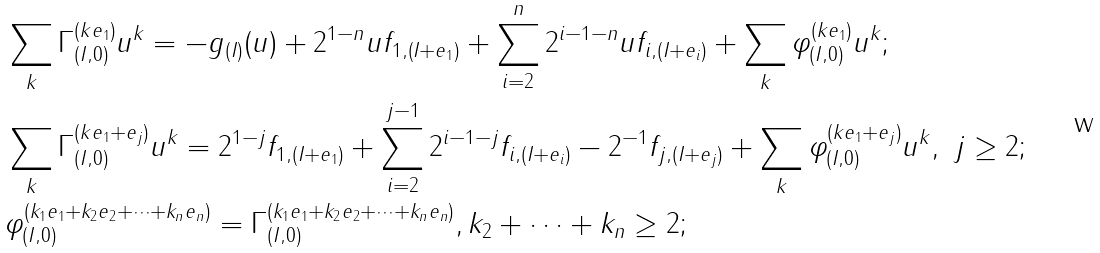<formula> <loc_0><loc_0><loc_500><loc_500>& \sum _ { k } \Gamma _ { ( I , 0 ) } ^ { ( k e _ { 1 } ) } u ^ { k } = - g _ { ( I ) } ( u ) + 2 ^ { 1 - n } u f _ { 1 , ( I + e _ { 1 } ) } + \sum _ { i = 2 } ^ { n } 2 ^ { i - 1 - n } u f _ { i , ( I + e _ { i } ) } + \sum _ { k } \varphi _ { ( I , 0 ) } ^ { ( k e _ { 1 } ) } u ^ { k } ; \\ & \sum _ { k } \Gamma _ { ( I , 0 ) } ^ { ( k e _ { 1 } + e _ { j } ) } u ^ { k } = 2 ^ { 1 - j } f _ { 1 , ( I + e _ { 1 } ) } + \sum _ { i = 2 } ^ { j - 1 } 2 ^ { i - 1 - j } f _ { i , ( I + e _ { i } ) } - 2 ^ { - 1 } f _ { j , ( I + e _ { j } ) } + \sum _ { k } \varphi _ { ( I , 0 ) } ^ { ( k e _ { 1 } + e _ { j } ) } u ^ { k } , \ j \geq 2 ; \\ & \varphi _ { ( I , 0 ) } ^ { ( k _ { 1 } e _ { 1 } + k _ { 2 } e _ { 2 } + \cdots + k _ { n } e _ { n } ) } = \Gamma _ { ( I , 0 ) } ^ { ( k _ { 1 } e _ { 1 } + k _ { 2 } e _ { 2 } + \cdots + k _ { n } e _ { n } ) } , k _ { 2 } + \cdots + k _ { n } \geq 2 ;</formula> 